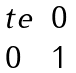Convert formula to latex. <formula><loc_0><loc_0><loc_500><loc_500>\begin{matrix} \ t e & 0 \\ 0 & 1 \end{matrix}</formula> 